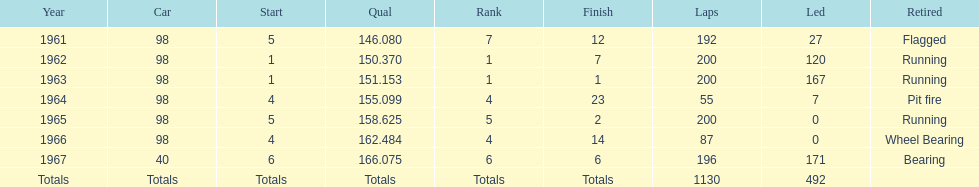How many consecutive years did parnelli place in the top 5? 5. 